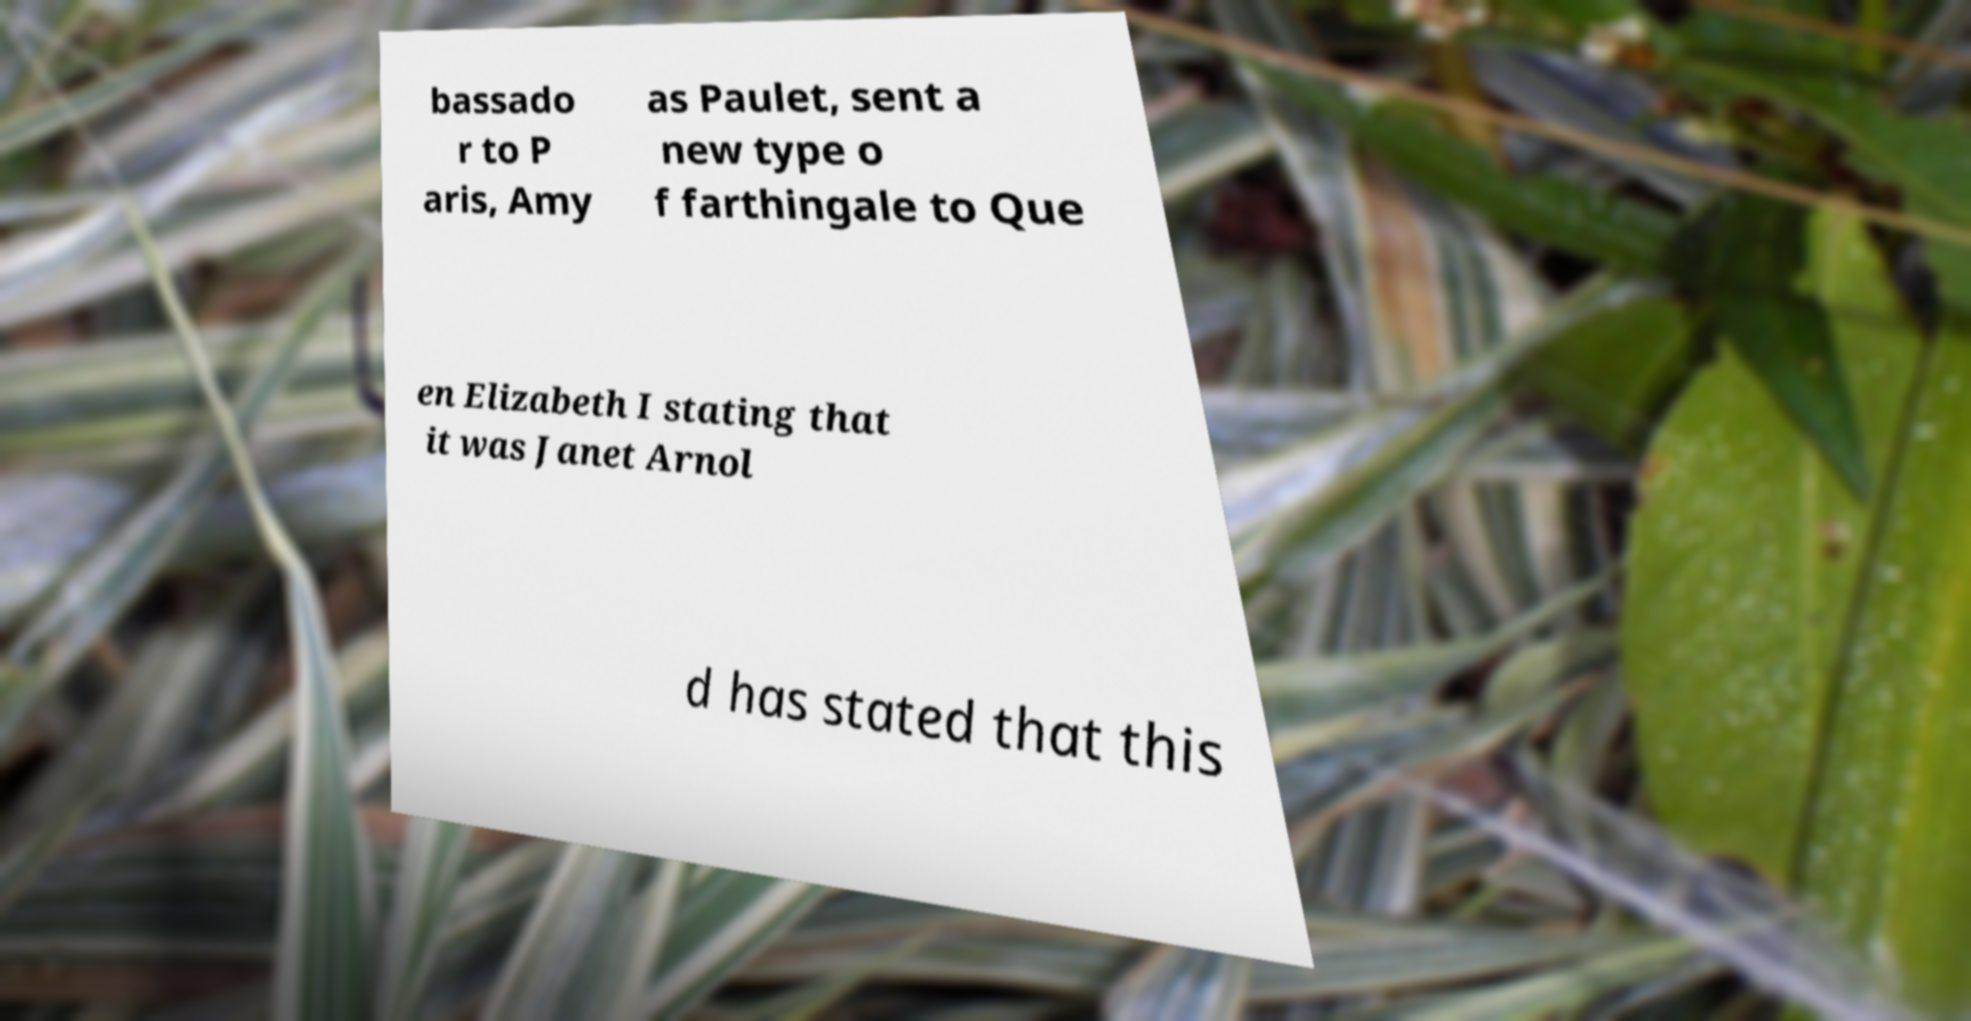Please identify and transcribe the text found in this image. bassado r to P aris, Amy as Paulet, sent a new type o f farthingale to Que en Elizabeth I stating that it was Janet Arnol d has stated that this 